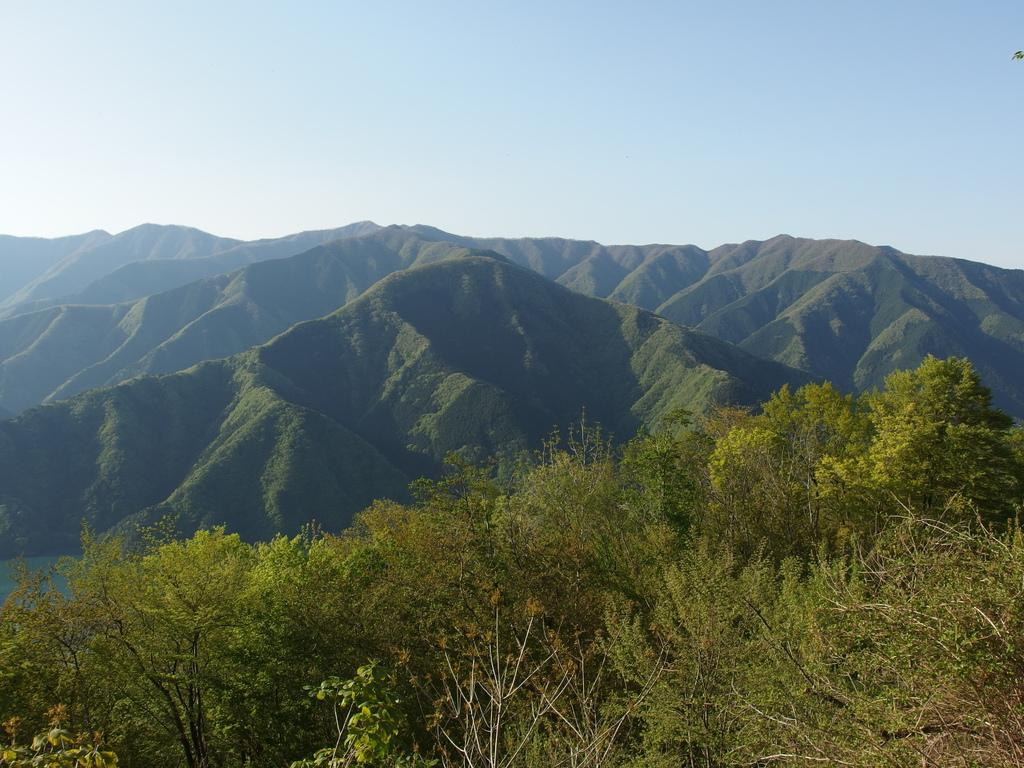What type of natural elements can be seen in the image? There are trees and mountains in the image. What is visible in the background of the image? The sky is visible in the background of the image. What type of juice is being served at the protest in the image? There is no protest or juice present in the image; it features trees, mountains, and the sky. 